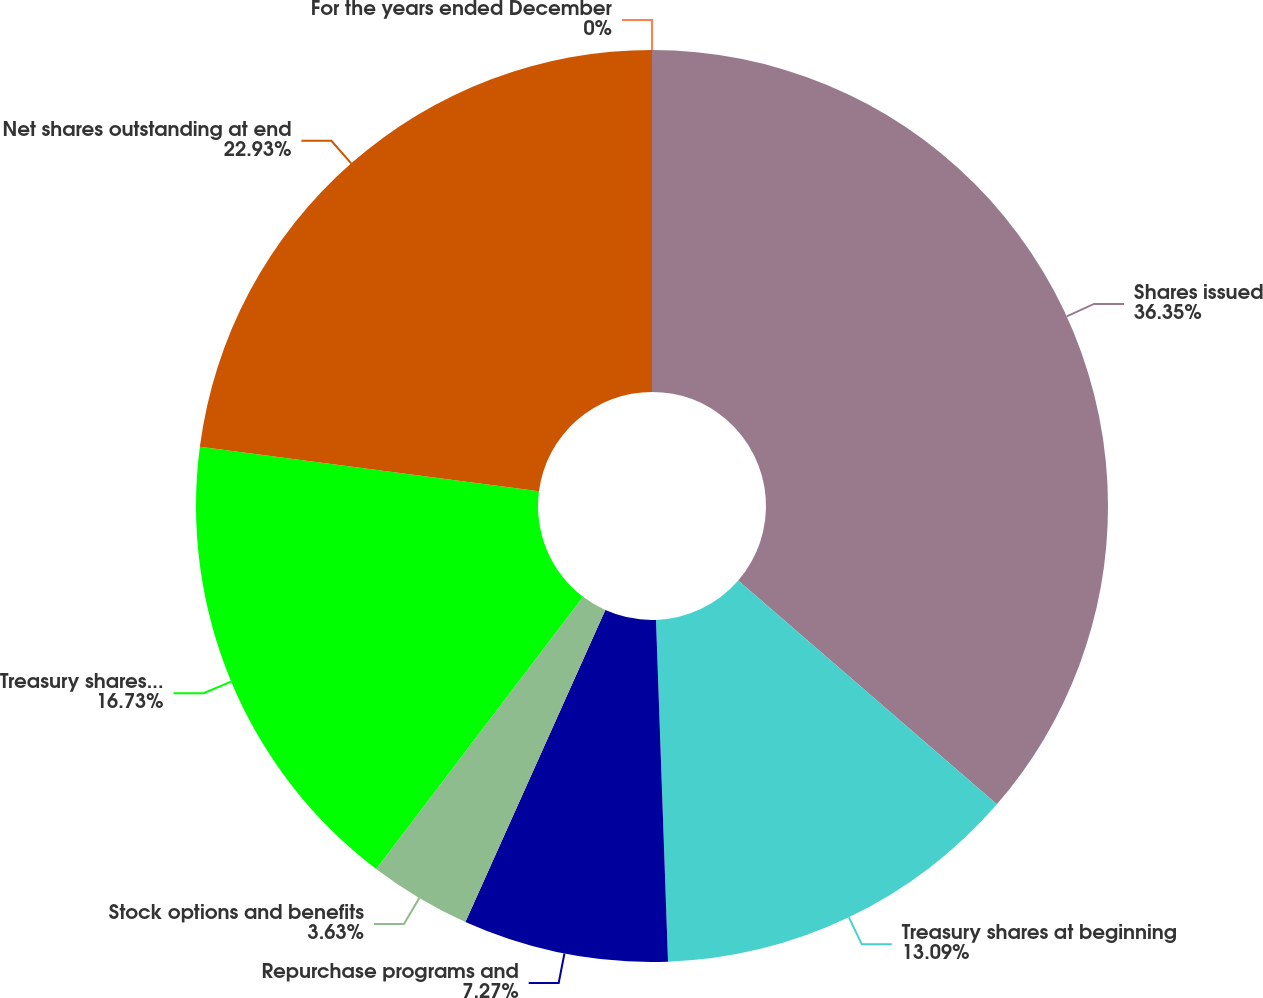Convert chart to OTSL. <chart><loc_0><loc_0><loc_500><loc_500><pie_chart><fcel>For the years ended December<fcel>Shares issued<fcel>Treasury shares at beginning<fcel>Repurchase programs and<fcel>Stock options and benefits<fcel>Treasury shares at end of year<fcel>Net shares outstanding at end<nl><fcel>0.0%<fcel>36.35%<fcel>13.09%<fcel>7.27%<fcel>3.63%<fcel>16.73%<fcel>22.93%<nl></chart> 